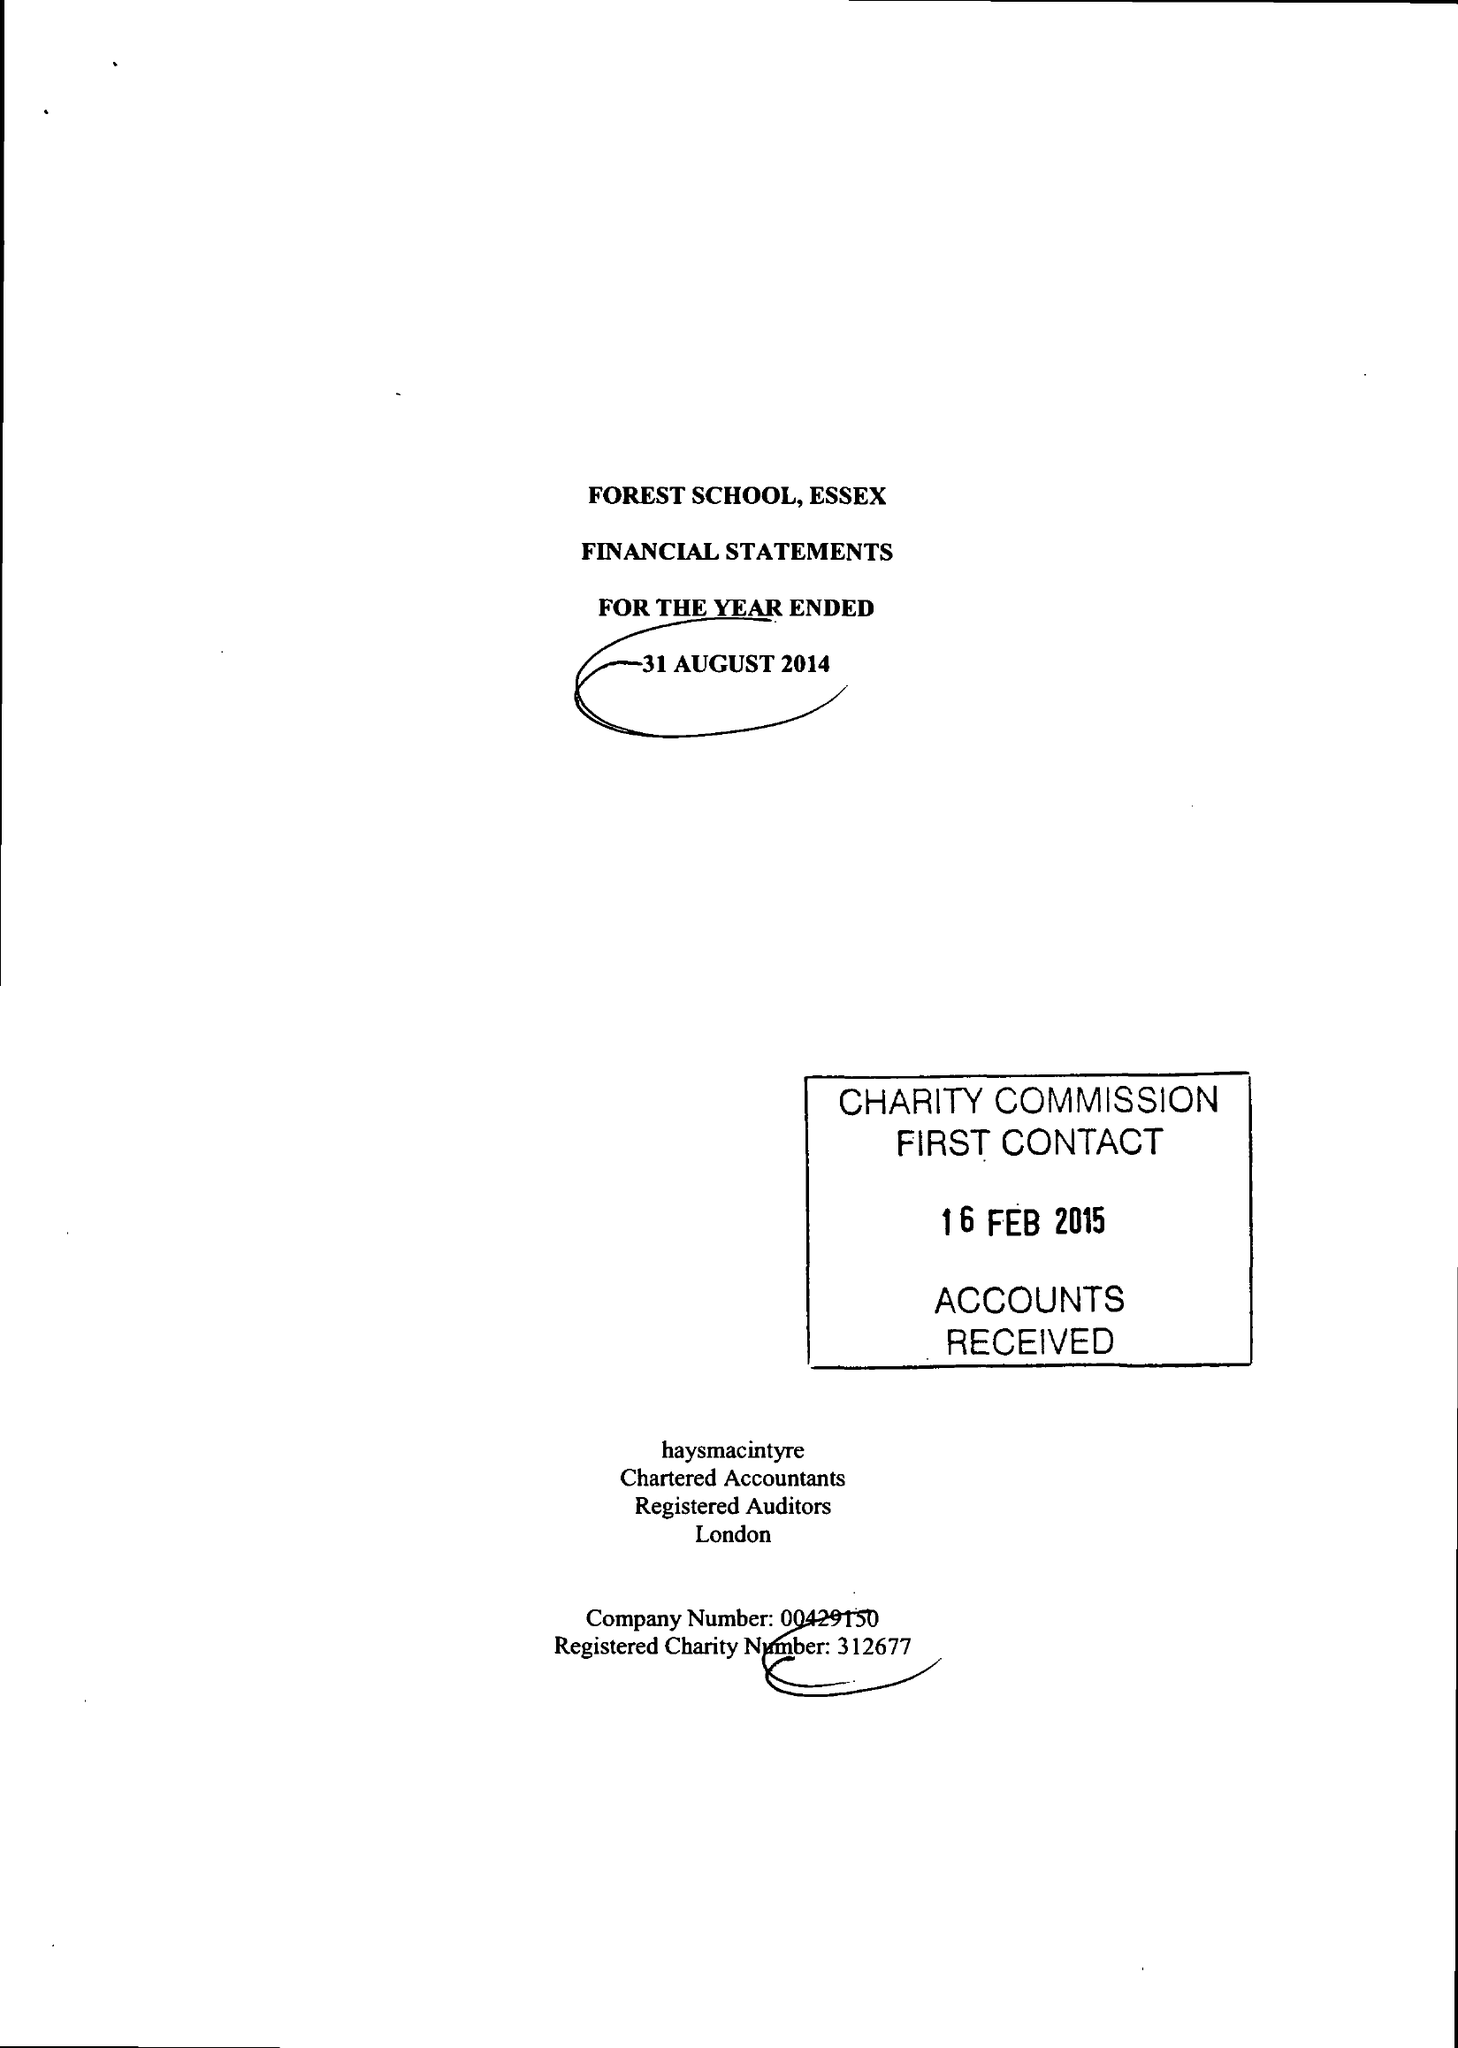What is the value for the address__post_town?
Answer the question using a single word or phrase. LONDON 